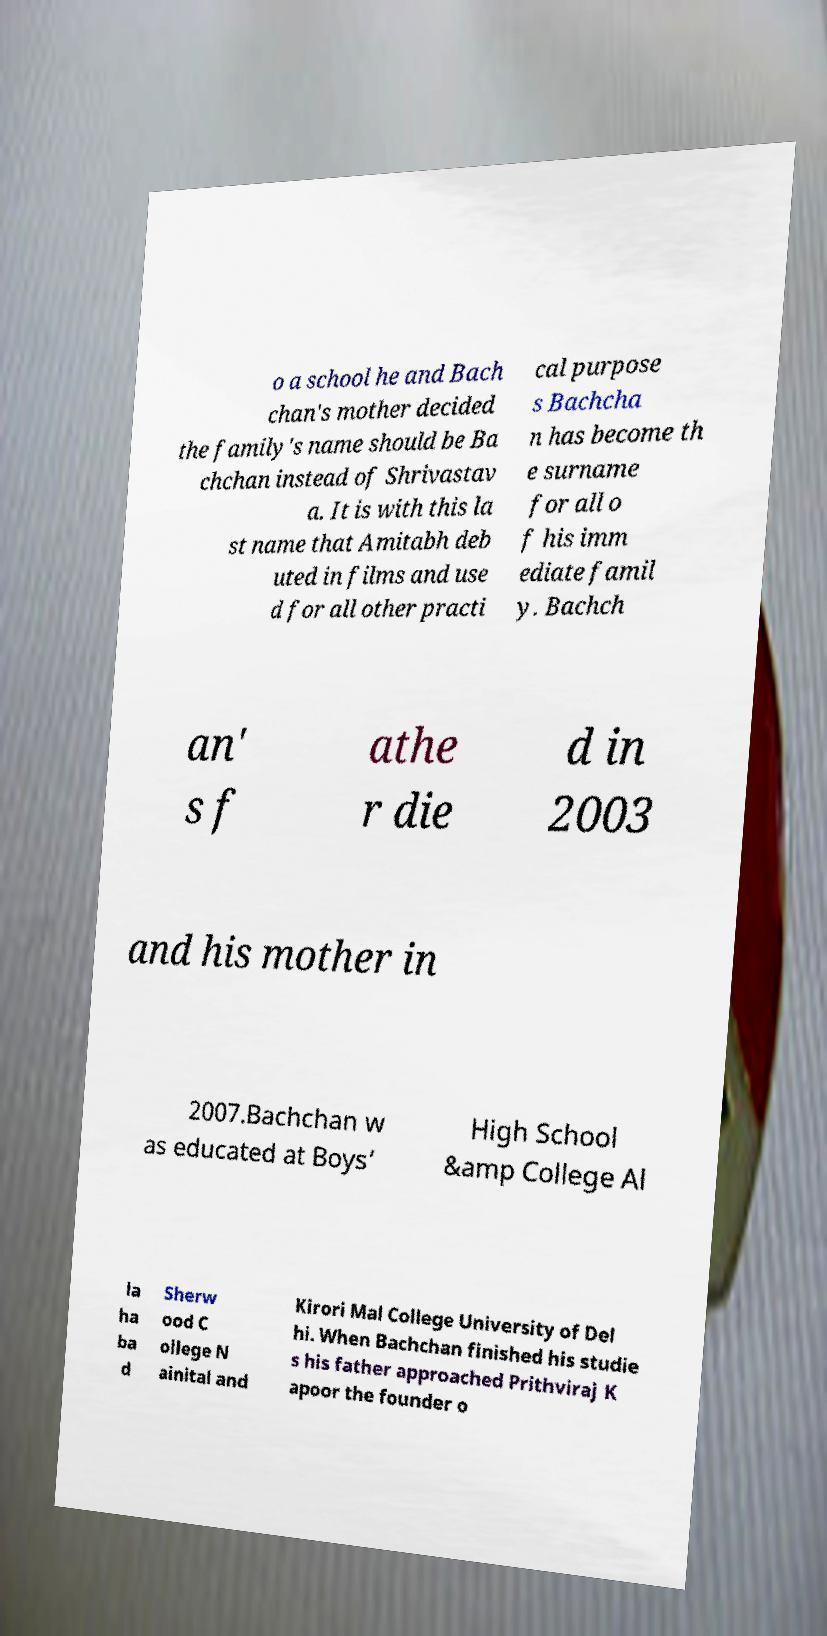There's text embedded in this image that I need extracted. Can you transcribe it verbatim? o a school he and Bach chan's mother decided the family's name should be Ba chchan instead of Shrivastav a. It is with this la st name that Amitabh deb uted in films and use d for all other practi cal purpose s Bachcha n has become th e surname for all o f his imm ediate famil y. Bachch an' s f athe r die d in 2003 and his mother in 2007.Bachchan w as educated at Boys’ High School &amp College Al la ha ba d Sherw ood C ollege N ainital and Kirori Mal College University of Del hi. When Bachchan finished his studie s his father approached Prithviraj K apoor the founder o 